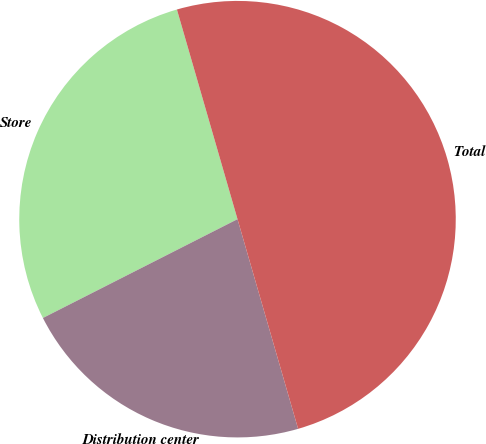Convert chart to OTSL. <chart><loc_0><loc_0><loc_500><loc_500><pie_chart><fcel>Store<fcel>Distribution center<fcel>Total<nl><fcel>28.0%<fcel>22.0%<fcel>50.0%<nl></chart> 